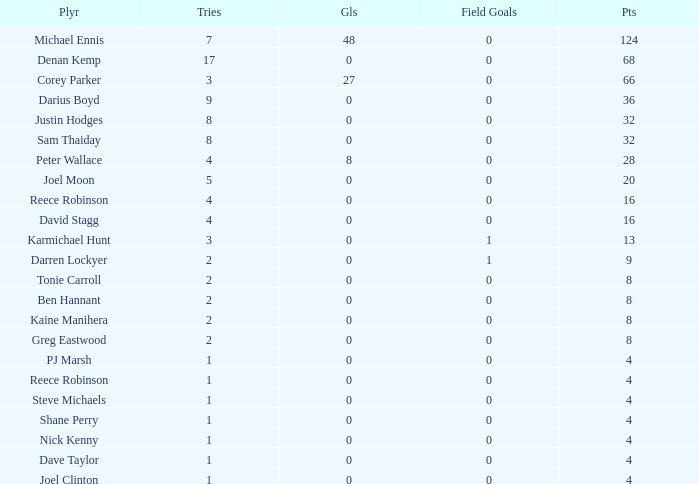What is the lowest tries the player with more than 0 goals, 28 points, and more than 0 field goals have? None. 